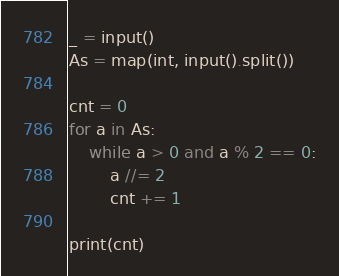Convert code to text. <code><loc_0><loc_0><loc_500><loc_500><_Python_>_ = input()
As = map(int, input().split())

cnt = 0
for a in As:
    while a > 0 and a % 2 == 0:
        a //= 2
        cnt += 1

print(cnt)
</code> 